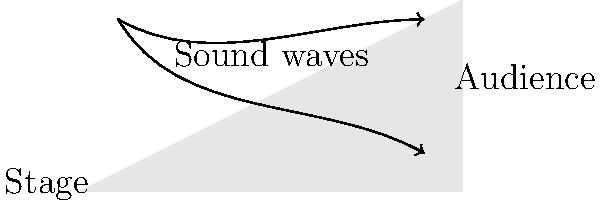In the design of an ancient Greek amphitheater, how does the curved seating arrangement contribute to the acoustic properties of the space, and what principle of sound reflection is utilized? To understand the acoustic properties of an ancient Greek amphitheater, we need to consider the following steps:

1. Geometry: The amphitheater has a semi-circular or elliptical shape with tiered seating arranged in a curved pattern.

2. Sound propagation: Sound waves emanate from the stage area in all directions.

3. Reflection principle: Sound waves follow the law of reflection, where the angle of incidence equals the angle of reflection.

4. Curved surface effect: The curved seating arrangement acts as a concave reflector for sound waves.

5. Focus of sound: The concave shape focuses the reflected sound waves towards the audience.

6. Reinforcement: This focusing effect reinforces the sound, making it louder and clearer for the audience.

7. Reduced echo: The curved shape also helps to minimize echoes by directing reflected sound in a controlled manner.

8. Even distribution: The curvature ensures a more even distribution of sound throughout the seating area.

9. Natural amplification: This design creates a natural amplification system without the need for modern electronic equipment.

10. Principle utilized: This acoustic design employs the principle of geometric focusing of sound waves.
Answer: Geometric focusing of sound waves 